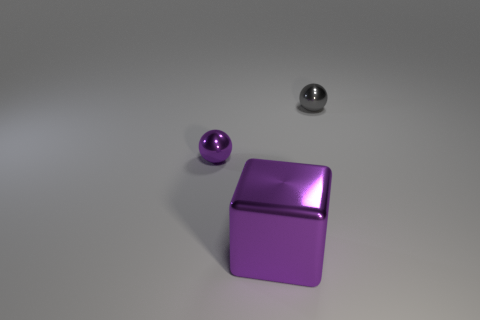Add 2 shiny things. How many objects exist? 5 Subtract all cubes. How many objects are left? 2 Subtract all large purple metallic things. Subtract all cubes. How many objects are left? 1 Add 2 big objects. How many big objects are left? 3 Add 3 cyan rubber things. How many cyan rubber things exist? 3 Subtract 0 red cylinders. How many objects are left? 3 